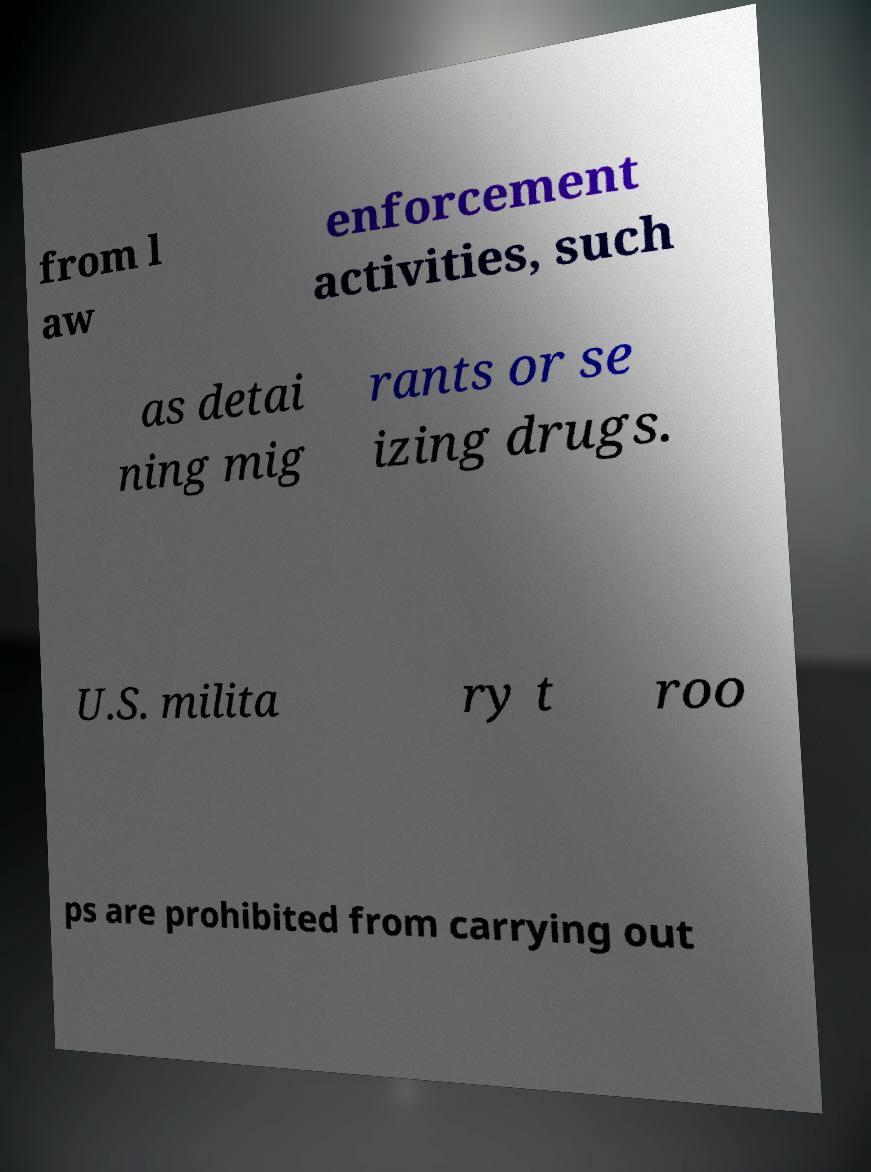For documentation purposes, I need the text within this image transcribed. Could you provide that? from l aw enforcement activities, such as detai ning mig rants or se izing drugs. U.S. milita ry t roo ps are prohibited from carrying out 